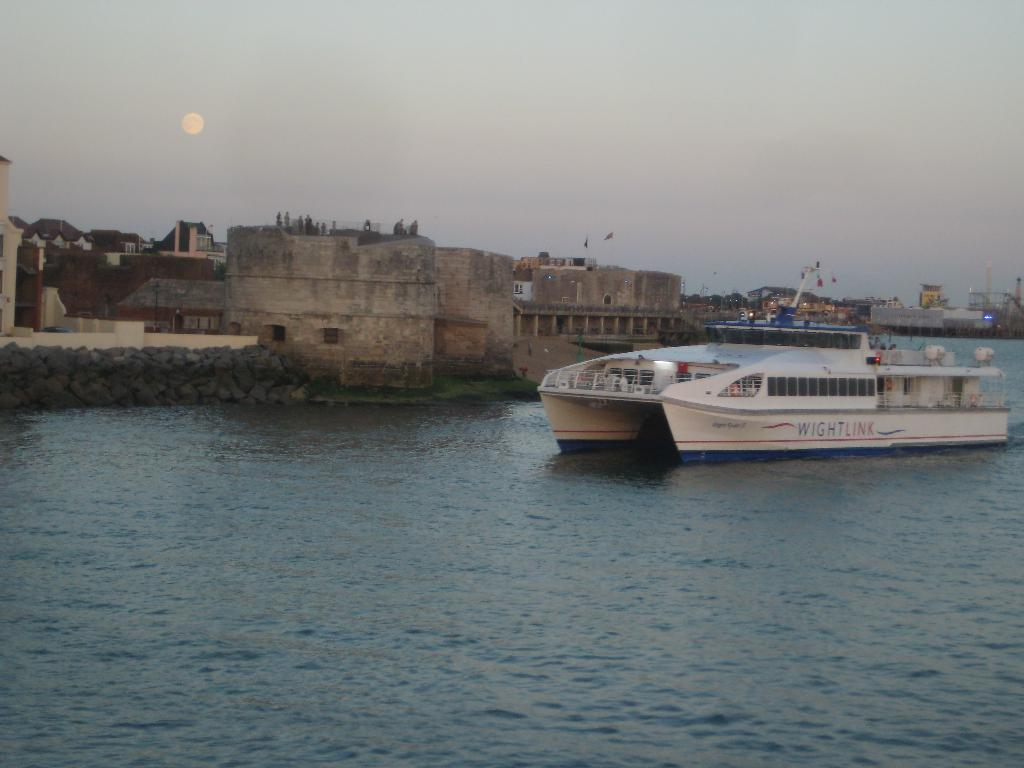What is the main subject of the image? There is a ship in the image. Where is the ship located? The ship is on a river. What can be seen in the background of the image? There are buildings and the sky visible in the background of the image. What type of rat can be seen in the aftermath of the ship's journey in the image? There is no rat present in the image, nor is there any indication of an aftermath of the ship's journey. 